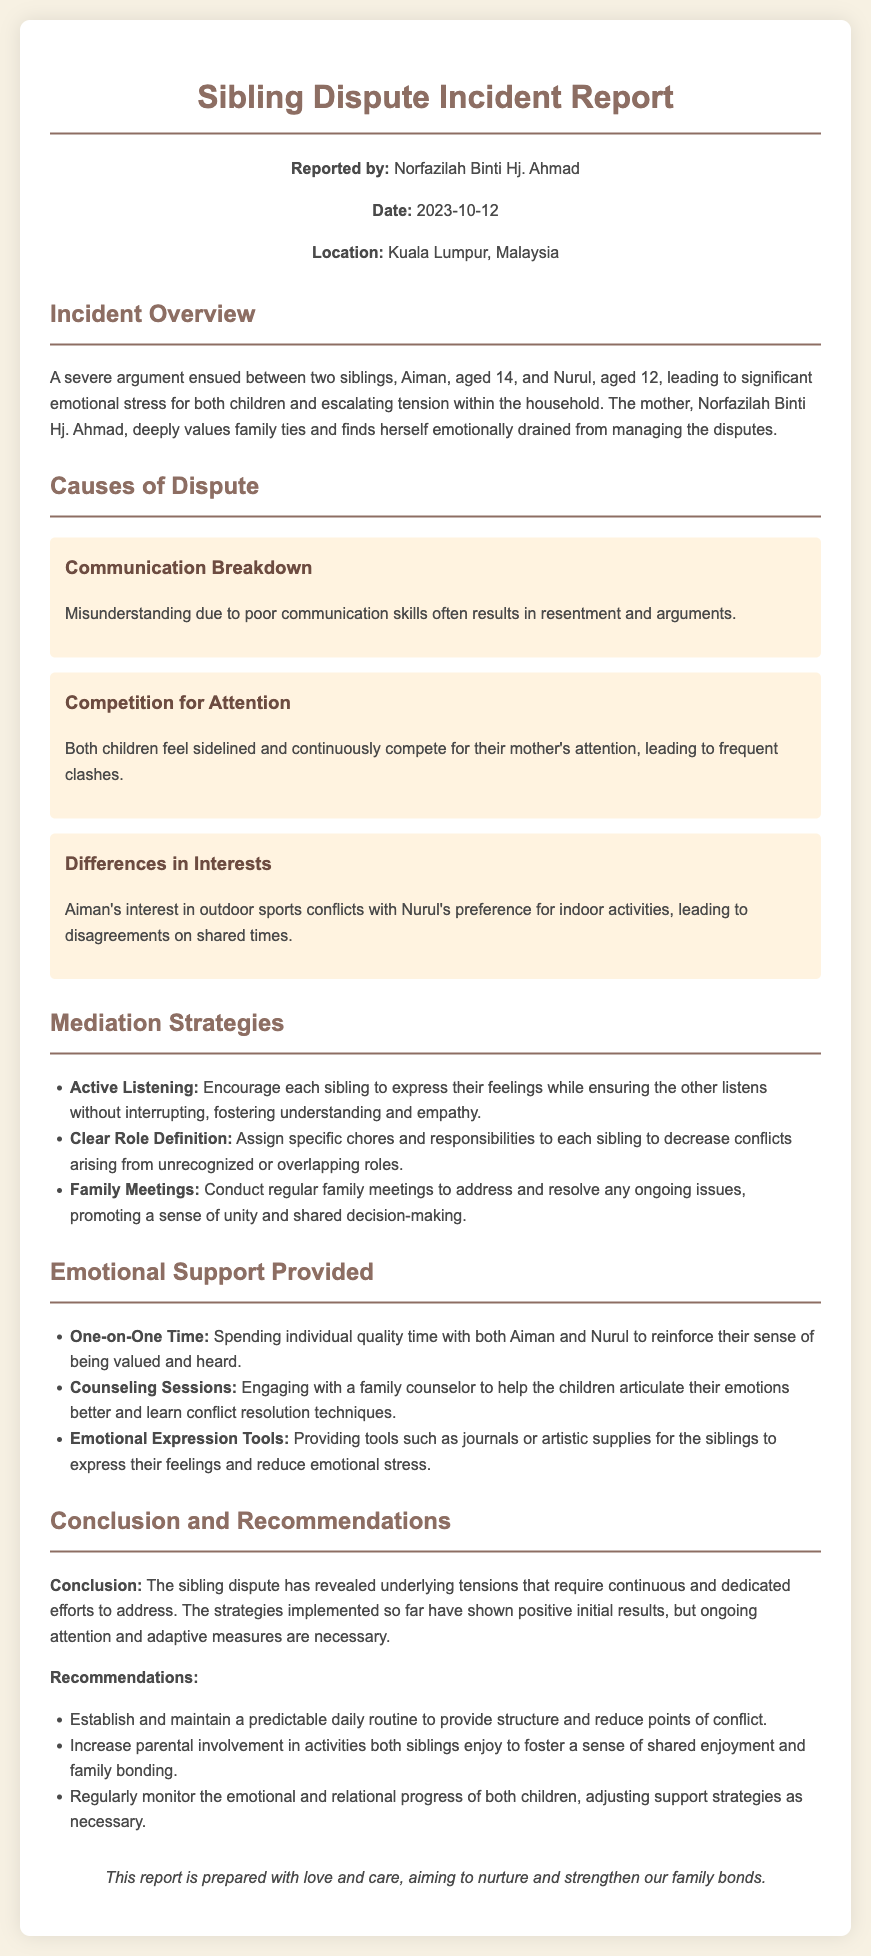what is the name of the reporter? The report lists the name of the reporter as Norfazilah Binti Hj. Ahmad.
Answer: Norfazilah Binti Hj. Ahmad what are the ages of the siblings involved in the dispute? The document specifies Aiman is 14 years old and Nurul is 12 years old.
Answer: 14 and 12 what was the date of the incident report? The report states that it was dated October 12, 2023.
Answer: 2023-10-12 what is one cause of the sibling dispute mentioned? The document mentions communication breakdown as a cause of the dispute.
Answer: Communication Breakdown how many mediation strategies are listed in the report? There are three mediation strategies mentioned in the report.
Answer: Three what is one emotional support strategy provided? The report includes spending one-on-one time with each sibling as an emotional support strategy.
Answer: One-on-One Time what is the location of the incident? The report specifies that the location of the incident is Kuala Lumpur, Malaysia.
Answer: Kuala Lumpur, Malaysia what was one recommendation given in the report? The report recommends establishing and maintaining a predictable daily routine.
Answer: Predictable daily routine 